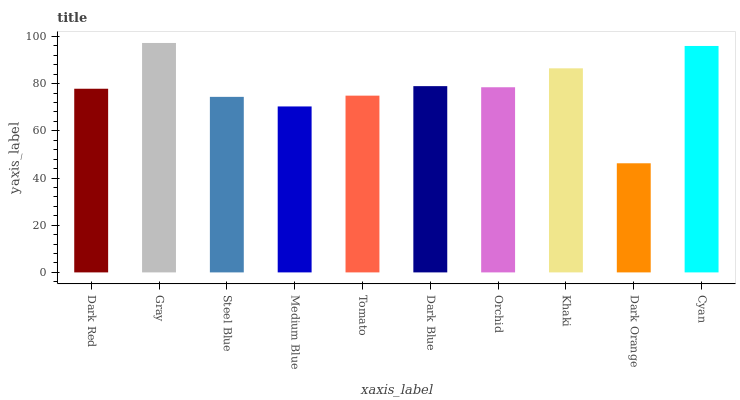Is Dark Orange the minimum?
Answer yes or no. Yes. Is Gray the maximum?
Answer yes or no. Yes. Is Steel Blue the minimum?
Answer yes or no. No. Is Steel Blue the maximum?
Answer yes or no. No. Is Gray greater than Steel Blue?
Answer yes or no. Yes. Is Steel Blue less than Gray?
Answer yes or no. Yes. Is Steel Blue greater than Gray?
Answer yes or no. No. Is Gray less than Steel Blue?
Answer yes or no. No. Is Orchid the high median?
Answer yes or no. Yes. Is Dark Red the low median?
Answer yes or no. Yes. Is Khaki the high median?
Answer yes or no. No. Is Dark Orange the low median?
Answer yes or no. No. 